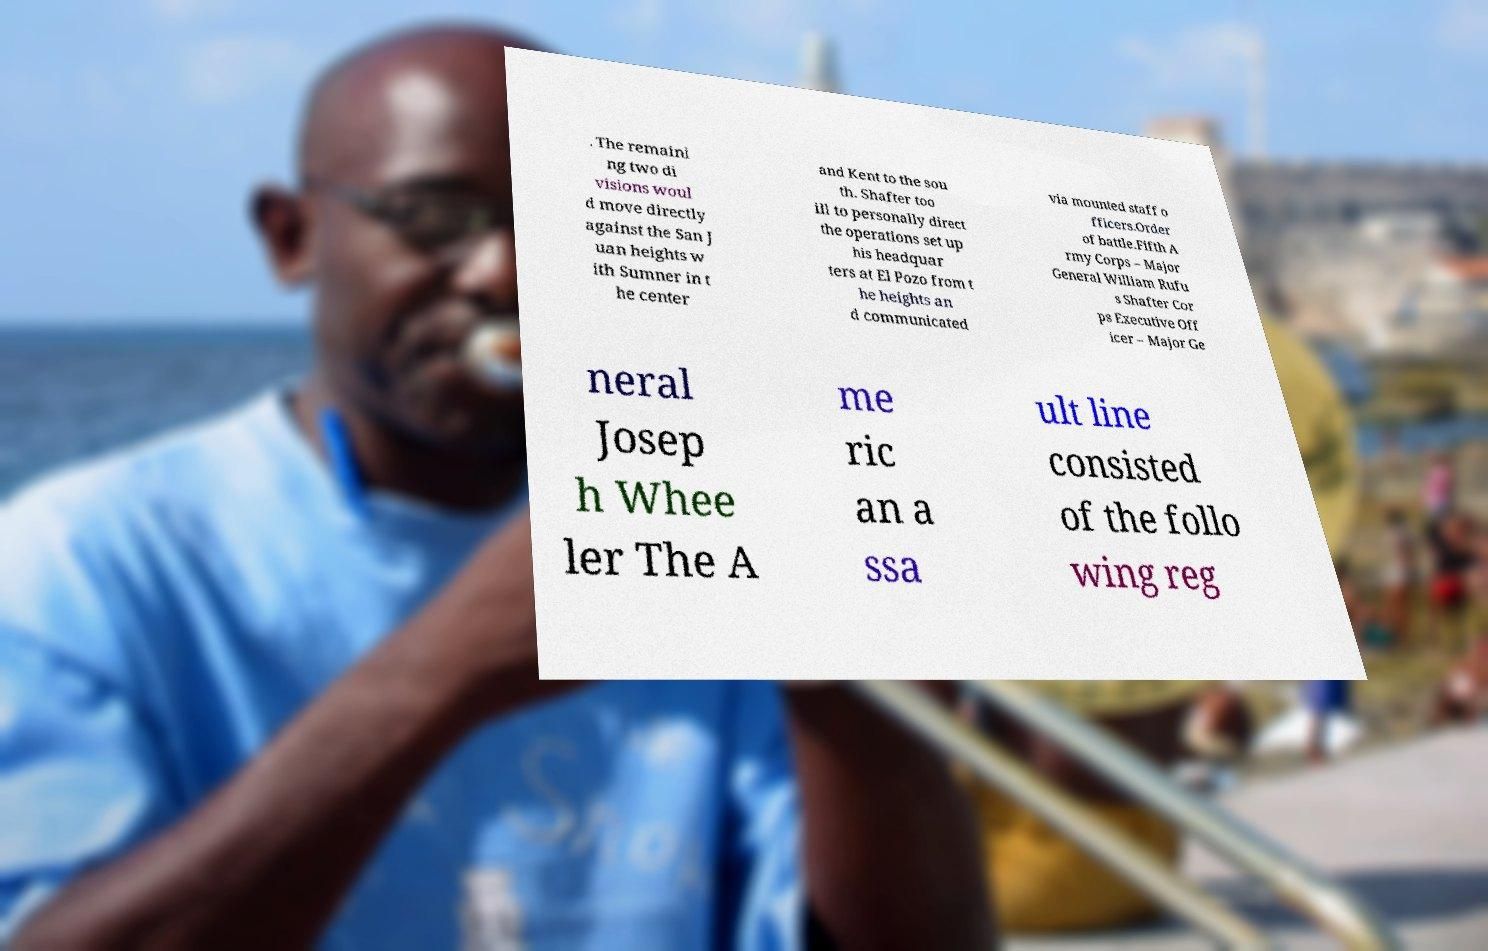Please read and relay the text visible in this image. What does it say? . The remaini ng two di visions woul d move directly against the San J uan heights w ith Sumner in t he center and Kent to the sou th. Shafter too ill to personally direct the operations set up his headquar ters at El Pozo from t he heights an d communicated via mounted staff o fficers.Order of battle.Fifth A rmy Corps – Major General William Rufu s Shafter Cor ps Executive Off icer – Major Ge neral Josep h Whee ler The A me ric an a ssa ult line consisted of the follo wing reg 